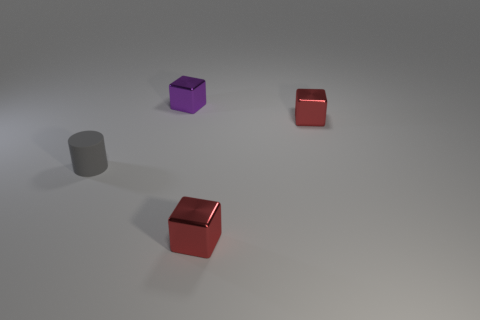Add 4 big cylinders. How many objects exist? 8 Subtract all cubes. How many objects are left? 1 Add 3 tiny purple metal objects. How many tiny purple metal objects are left? 4 Add 4 large yellow cubes. How many large yellow cubes exist? 4 Subtract 0 purple spheres. How many objects are left? 4 Subtract all cylinders. Subtract all shiny objects. How many objects are left? 0 